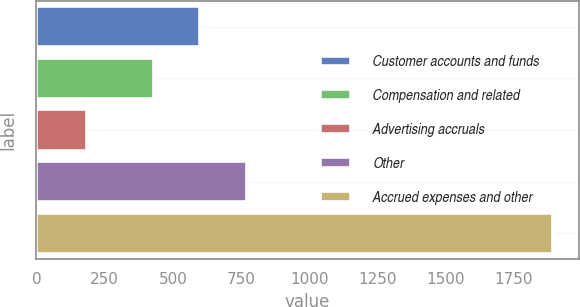Convert chart. <chart><loc_0><loc_0><loc_500><loc_500><bar_chart><fcel>Customer accounts and funds<fcel>Compensation and related<fcel>Advertising accruals<fcel>Other<fcel>Accrued expenses and other<nl><fcel>600.9<fcel>430<fcel>184<fcel>771.8<fcel>1893<nl></chart> 